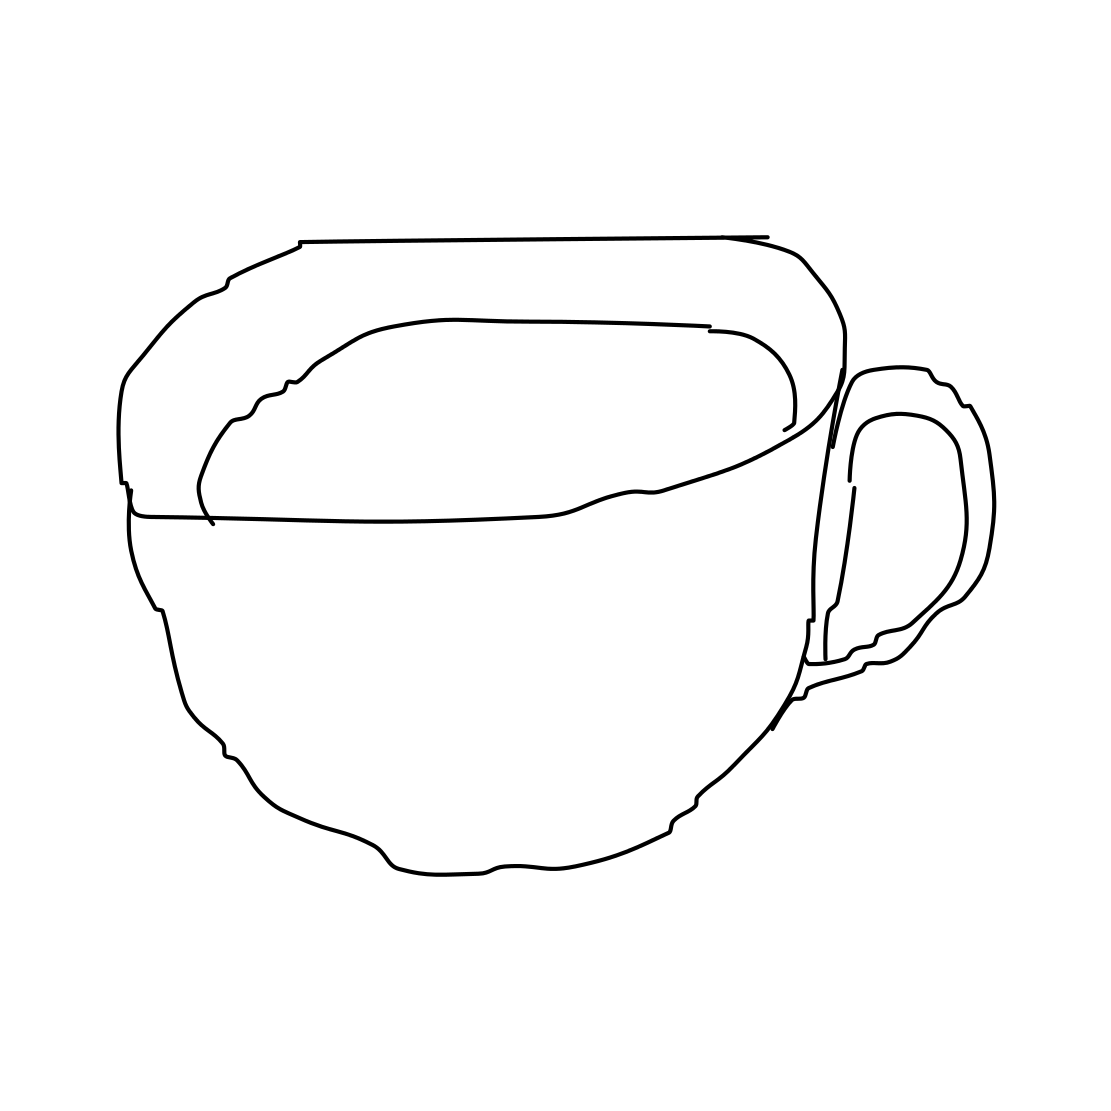What kind of cup is shown in this image? The image displays a simple line drawing of a standard cup, which appears to be a type of mug typically used for hot beverages due to its handle. 